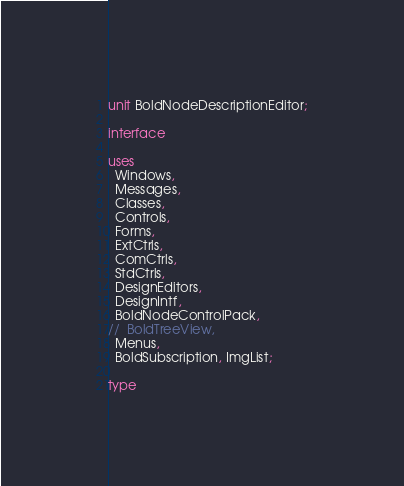Convert code to text. <code><loc_0><loc_0><loc_500><loc_500><_Pascal_>unit BoldNodeDescriptionEditor;

interface

uses
  Windows,
  Messages,
  Classes,
  Controls,
  Forms,
  ExtCtrls,
  ComCtrls,
  StdCtrls,
  DesignEditors,
  DesignIntf,
  BoldNodeControlPack,
//  BoldTreeView,
  Menus,
  BoldSubscription, ImgList;

type</code> 